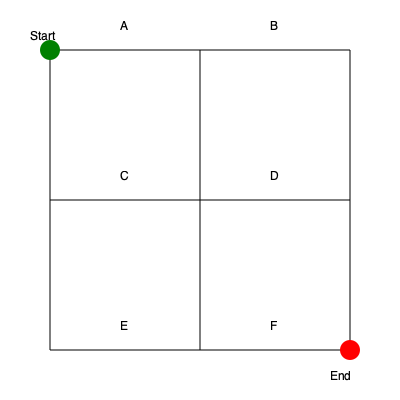As a supportive manager, you want to help your mail carrier optimize their delivery route. Given the simplified city map above with intersections labeled A through F, what is the shortest path from Start to End, passing through all intersections exactly once? To find the shortest path, we need to consider all possible routes that visit each intersection once. Let's break it down step-by-step:

1. Start at the green circle (top-left corner).
2. We must visit all intersections A, B, C, D, E, and F exactly once before reaching the red circle (bottom-right corner).
3. The possible paths are:
   - Start → A → B → C → D → E → F → End
   - Start → A → C → B → D → E → F → End
   - Start → A → C → E → B → D → F → End
   - Start → A → C → E → D → B → F → End

4. To determine the shortest path, we need to compare the total distances:
   - Path 1: 6 block lengths
   - Path 2: 6 block lengths
   - Path 3: 6 block lengths
   - Path 4: 6 block lengths

5. All paths have the same length of 6 block lengths.

6. However, considering the mail carrier's efficiency, we should choose a path that minimizes backtracking and allows for a smooth flow of deliveries.

7. The path that best meets this criterion is: Start → A → C → E → D → B → F → End

This path allows the mail carrier to move in a generally consistent direction (left to right, top to bottom) without any significant backtracking, which is ideal for efficient mail delivery.
Answer: Start → A → C → E → D → B → F → End 